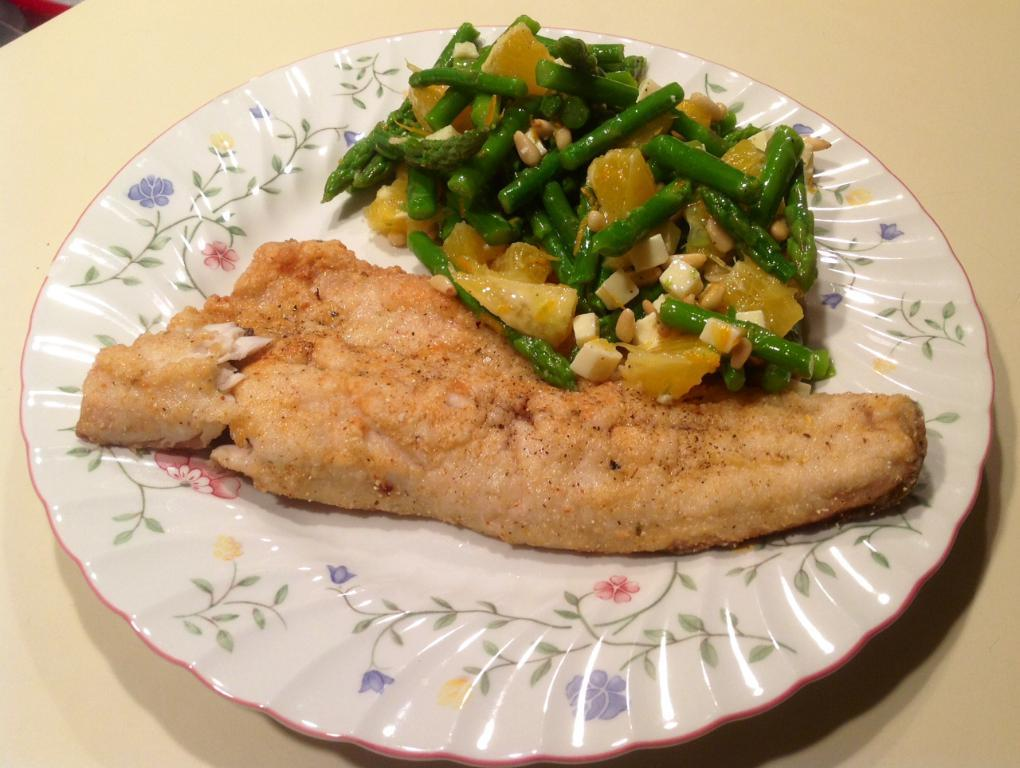What is on the table in the image? There is a plate on the table in the image. What is on the plate? The plate contains meat and vegetables. What type of bag is hanging on the wall in the image? There is no bag present in the image; it only features a plate with meat and vegetables on a table. 